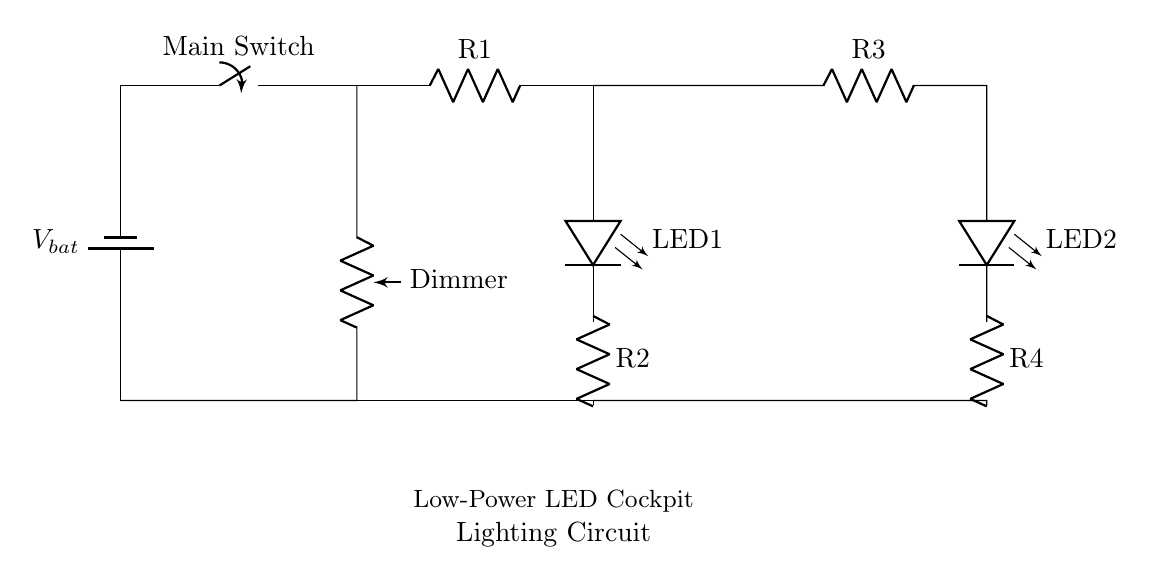What type of components are used in this circuit? The circuit contains a battery, switches, resistors, potentiometers, and LEDs, all of which are standard components used in low-power circuits.
Answer: battery, switch, resistor, potentiometer, LED What is the function of the dimmer in this circuit? The dimmer is a potentiometer that adjusts the brightness of the LEDs by changing the resistance in the circuit, thus regulating the current flowing through the LEDs.
Answer: adjust brightness How many LEDs are present in this circuit? There are two LEDs present in the circuit, each connected to a separate path for lighting.
Answer: two What is the role of the resistors in this circuit design? The resistors (R1, R2, R3, and R4) limit the current flowing to the LEDs, preventing them from drawing too much current and potentially burning out.
Answer: limit current What happens to the LED brightness if the potentiometer is turned down? Turning down the potentiometer increases the resistance, leading to a decrease in current through the LEDs, resulting in dimmer lights.
Answer: decreases brightness Is this circuit suitable for high-power applications? No, this circuit is designed for low-power applications, making it unsuitable for high-power capabilities due to the components used.
Answer: no 